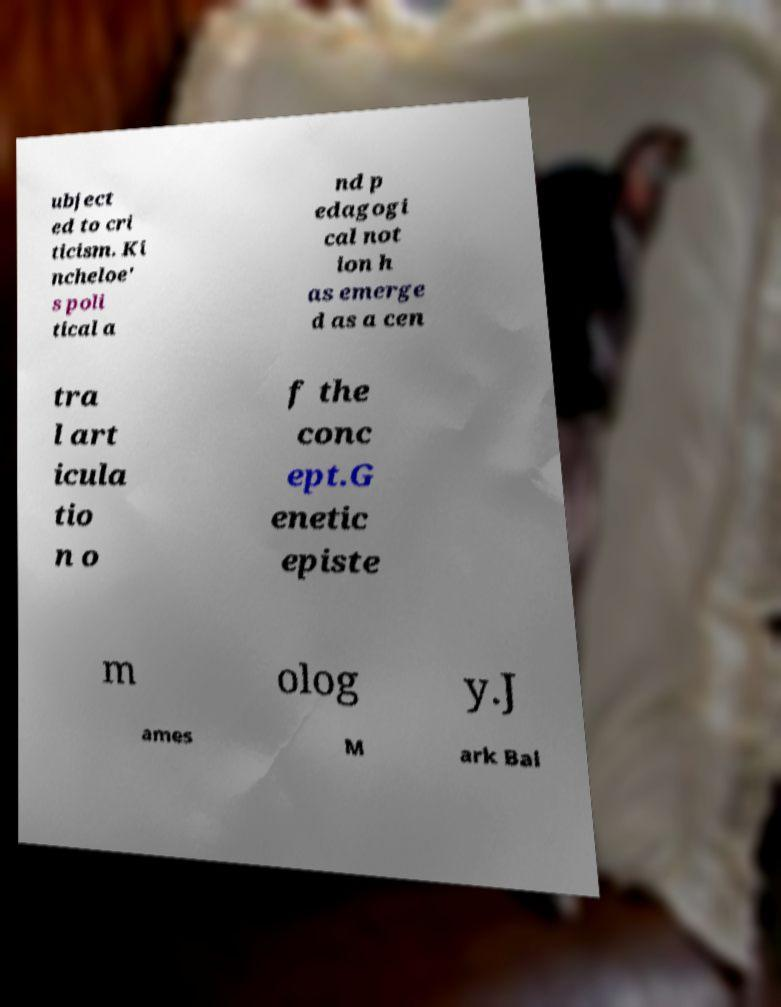I need the written content from this picture converted into text. Can you do that? ubject ed to cri ticism. Ki ncheloe' s poli tical a nd p edagogi cal not ion h as emerge d as a cen tra l art icula tio n o f the conc ept.G enetic episte m olog y.J ames M ark Bal 